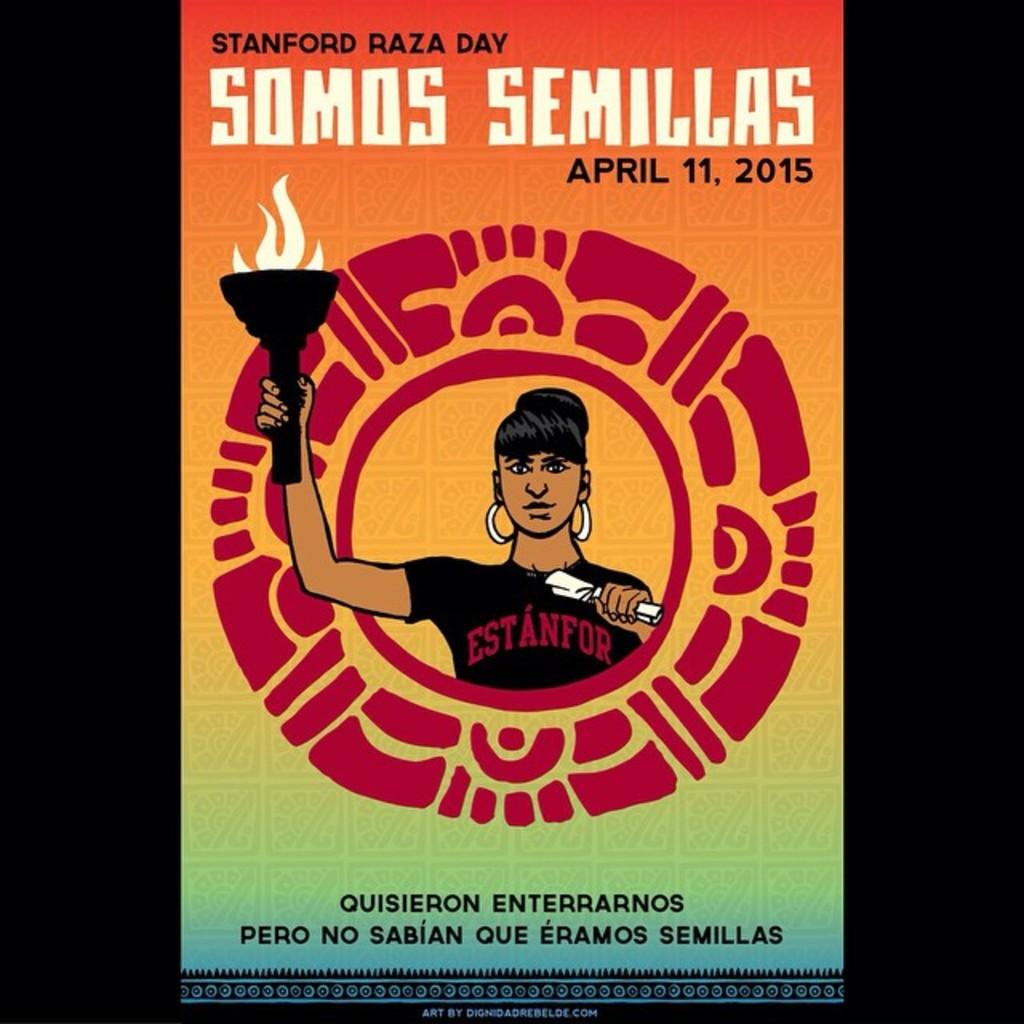<image>
Relay a brief, clear account of the picture shown. A poster for Stanford Raza Day April 11, 2015. 